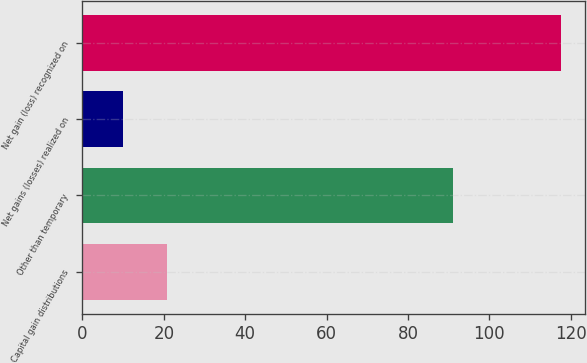<chart> <loc_0><loc_0><loc_500><loc_500><bar_chart><fcel>Capital gain distributions<fcel>Other than temporary<fcel>Net gains (losses) realized on<fcel>Net gain (loss) recognized on<nl><fcel>20.75<fcel>91<fcel>10<fcel>117.5<nl></chart> 